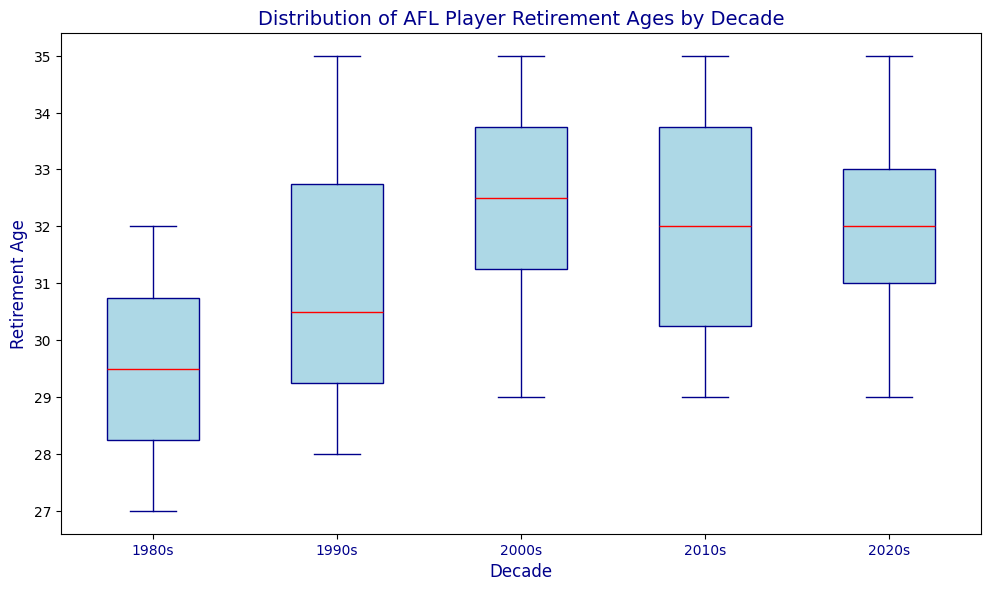What is the median retirement age for players in the 2000s? The median is shown by the red line inside the box for the 2000s.
Answer: 32 Which decade has the largest interquartile range (IQR) for retirement ages? The IQR is the range between the first quartile (bottom of the box) and the third quartile (top of the box). Identify which box is the widest vertically.
Answer: 2020s How does the median retirement age in the 1980s compare to the 2010s? Compare the position of the red lines inside the boxes for the 1980s and the 2010s.
Answer: The median is higher in the 2010s In which decade do players have the lowest median retirement age? Identify the box with the lowest median (red line).
Answer: 1980s Which decade has the smallest range of retirement ages? The range is the distance between the lowest and highest points (whiskers). Identify which decade's whiskers cover the shortest span.
Answer: 2010s What is the median retirement age across all decades combined? Find the median (middle value) retirement age of all listed players in the data, considering all decades together. We need the comprehensive median (between the lowest and highest medians of each decade). The median value would have to be checked computationally by ordering all the ages. Given consistency of medians we assume the closest overall decade reflected might match.
Answer: Around 32 Compare the highest whisker in the 1990s to the highest whisker in the 2000s. Look at the top ends of the whiskers for both the 1990s and 2000s. Compare their values.
Answer: The highest whisker is the same, at 35 Which decade shows the least variation in retirement age? The variability can be inferred from the length of the interquartile range (IQR) and the range. Identify the decade where these are the shortest.
Answer: 2010s Which years had outliers in retirement ages? Outliers are shown as isolated points outside the whiskers of the boxes. Identify if any decades have such points.
Answer: None What is the range of retirement ages in the 1980s? Identify the smallest and largest values within the whiskers for the 1980s and compute the range (difference between maximum and minimum).
Answer: 27-32 (Range: 5) 